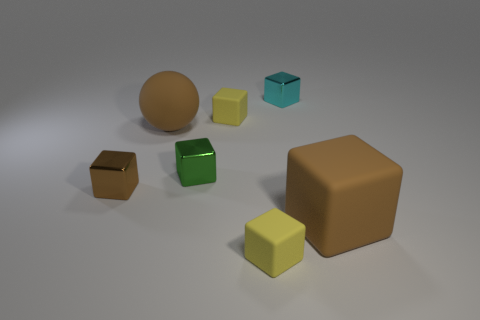There is a large object that is the same color as the large sphere; what is its shape?
Provide a short and direct response. Cube. Is there a rubber thing of the same color as the matte sphere?
Keep it short and to the point. Yes. What is the size of the matte thing that is the same color as the large block?
Make the answer very short. Large. There is a large rubber sphere; is its color the same as the large rubber object that is in front of the tiny brown thing?
Give a very brief answer. Yes. Is the size of the metallic cube that is to the left of the tiny green cube the same as the brown cube on the right side of the green object?
Provide a succinct answer. No. The tiny yellow thing behind the tiny yellow cube in front of the large object that is on the left side of the big brown block is made of what material?
Keep it short and to the point. Rubber. What is the size of the matte block that is both left of the cyan cube and in front of the small brown cube?
Your answer should be compact. Small. Do the tiny brown metallic thing and the tiny green metallic thing have the same shape?
Ensure brevity in your answer.  Yes. What is the shape of the brown thing that is the same material as the brown ball?
Make the answer very short. Cube. How many tiny things are yellow matte things or cubes?
Keep it short and to the point. 5. 